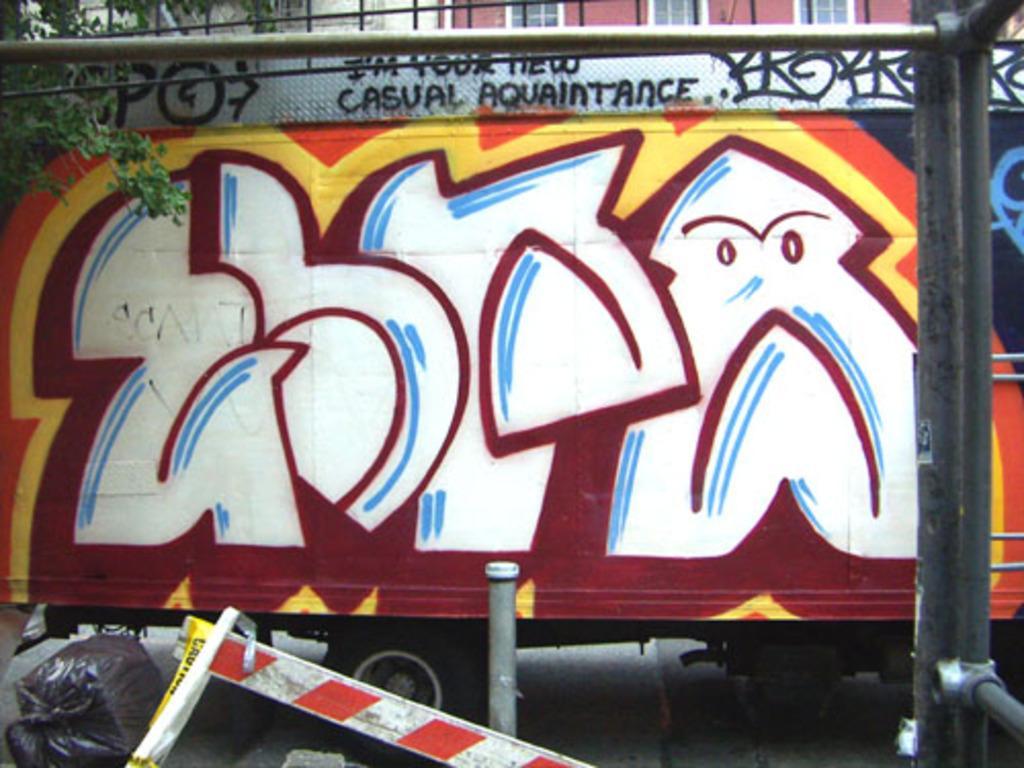Can you describe this image briefly? In this image I can see in the middle there is a painting on a vehicle, on the left side there is a tree. At the top it looks like a building. 